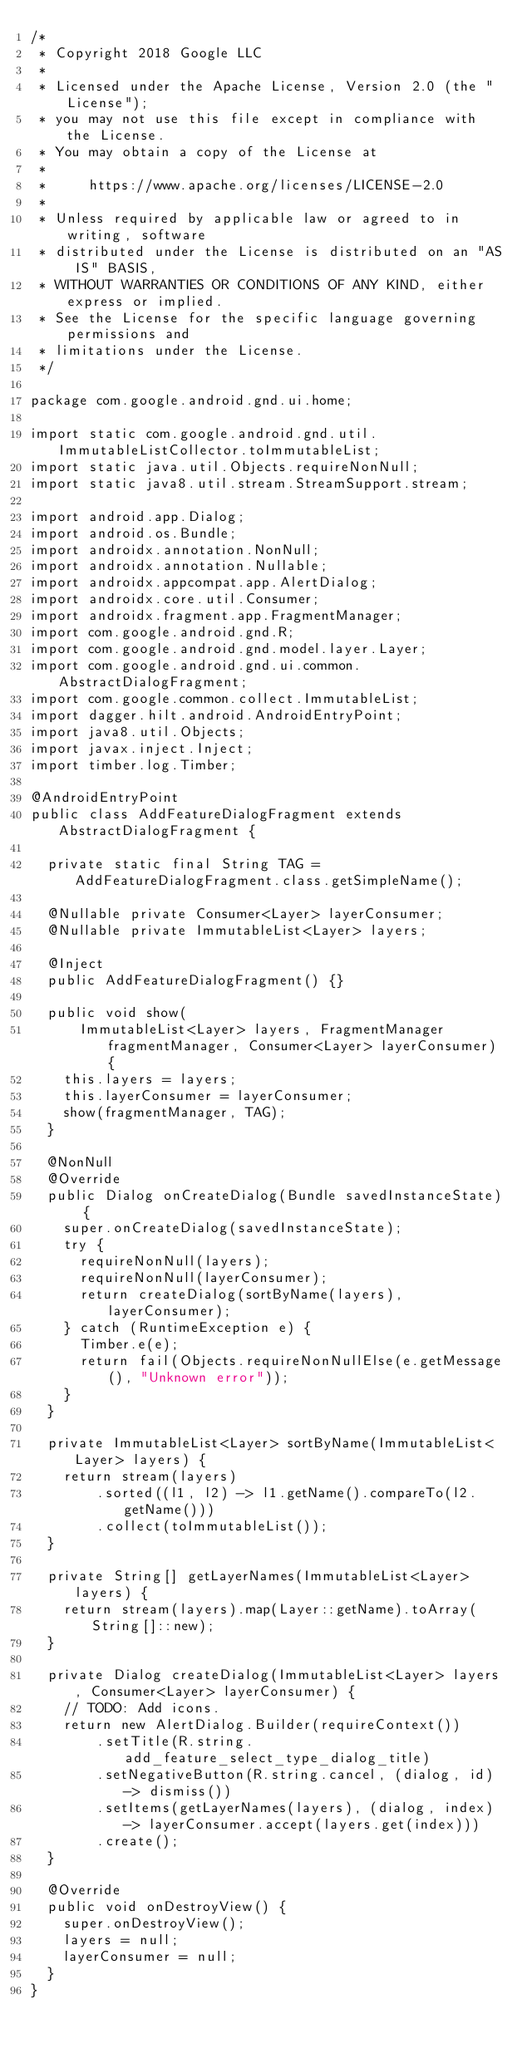<code> <loc_0><loc_0><loc_500><loc_500><_Java_>/*
 * Copyright 2018 Google LLC
 *
 * Licensed under the Apache License, Version 2.0 (the "License");
 * you may not use this file except in compliance with the License.
 * You may obtain a copy of the License at
 *
 *     https://www.apache.org/licenses/LICENSE-2.0
 *
 * Unless required by applicable law or agreed to in writing, software
 * distributed under the License is distributed on an "AS IS" BASIS,
 * WITHOUT WARRANTIES OR CONDITIONS OF ANY KIND, either express or implied.
 * See the License for the specific language governing permissions and
 * limitations under the License.
 */

package com.google.android.gnd.ui.home;

import static com.google.android.gnd.util.ImmutableListCollector.toImmutableList;
import static java.util.Objects.requireNonNull;
import static java8.util.stream.StreamSupport.stream;

import android.app.Dialog;
import android.os.Bundle;
import androidx.annotation.NonNull;
import androidx.annotation.Nullable;
import androidx.appcompat.app.AlertDialog;
import androidx.core.util.Consumer;
import androidx.fragment.app.FragmentManager;
import com.google.android.gnd.R;
import com.google.android.gnd.model.layer.Layer;
import com.google.android.gnd.ui.common.AbstractDialogFragment;
import com.google.common.collect.ImmutableList;
import dagger.hilt.android.AndroidEntryPoint;
import java8.util.Objects;
import javax.inject.Inject;
import timber.log.Timber;

@AndroidEntryPoint
public class AddFeatureDialogFragment extends AbstractDialogFragment {

  private static final String TAG = AddFeatureDialogFragment.class.getSimpleName();

  @Nullable private Consumer<Layer> layerConsumer;
  @Nullable private ImmutableList<Layer> layers;

  @Inject
  public AddFeatureDialogFragment() {}

  public void show(
      ImmutableList<Layer> layers, FragmentManager fragmentManager, Consumer<Layer> layerConsumer) {
    this.layers = layers;
    this.layerConsumer = layerConsumer;
    show(fragmentManager, TAG);
  }

  @NonNull
  @Override
  public Dialog onCreateDialog(Bundle savedInstanceState) {
    super.onCreateDialog(savedInstanceState);
    try {
      requireNonNull(layers);
      requireNonNull(layerConsumer);
      return createDialog(sortByName(layers), layerConsumer);
    } catch (RuntimeException e) {
      Timber.e(e);
      return fail(Objects.requireNonNullElse(e.getMessage(), "Unknown error"));
    }
  }

  private ImmutableList<Layer> sortByName(ImmutableList<Layer> layers) {
    return stream(layers)
        .sorted((l1, l2) -> l1.getName().compareTo(l2.getName()))
        .collect(toImmutableList());
  }

  private String[] getLayerNames(ImmutableList<Layer> layers) {
    return stream(layers).map(Layer::getName).toArray(String[]::new);
  }

  private Dialog createDialog(ImmutableList<Layer> layers, Consumer<Layer> layerConsumer) {
    // TODO: Add icons.
    return new AlertDialog.Builder(requireContext())
        .setTitle(R.string.add_feature_select_type_dialog_title)
        .setNegativeButton(R.string.cancel, (dialog, id) -> dismiss())
        .setItems(getLayerNames(layers), (dialog, index) -> layerConsumer.accept(layers.get(index)))
        .create();
  }

  @Override
  public void onDestroyView() {
    super.onDestroyView();
    layers = null;
    layerConsumer = null;
  }
}
</code> 